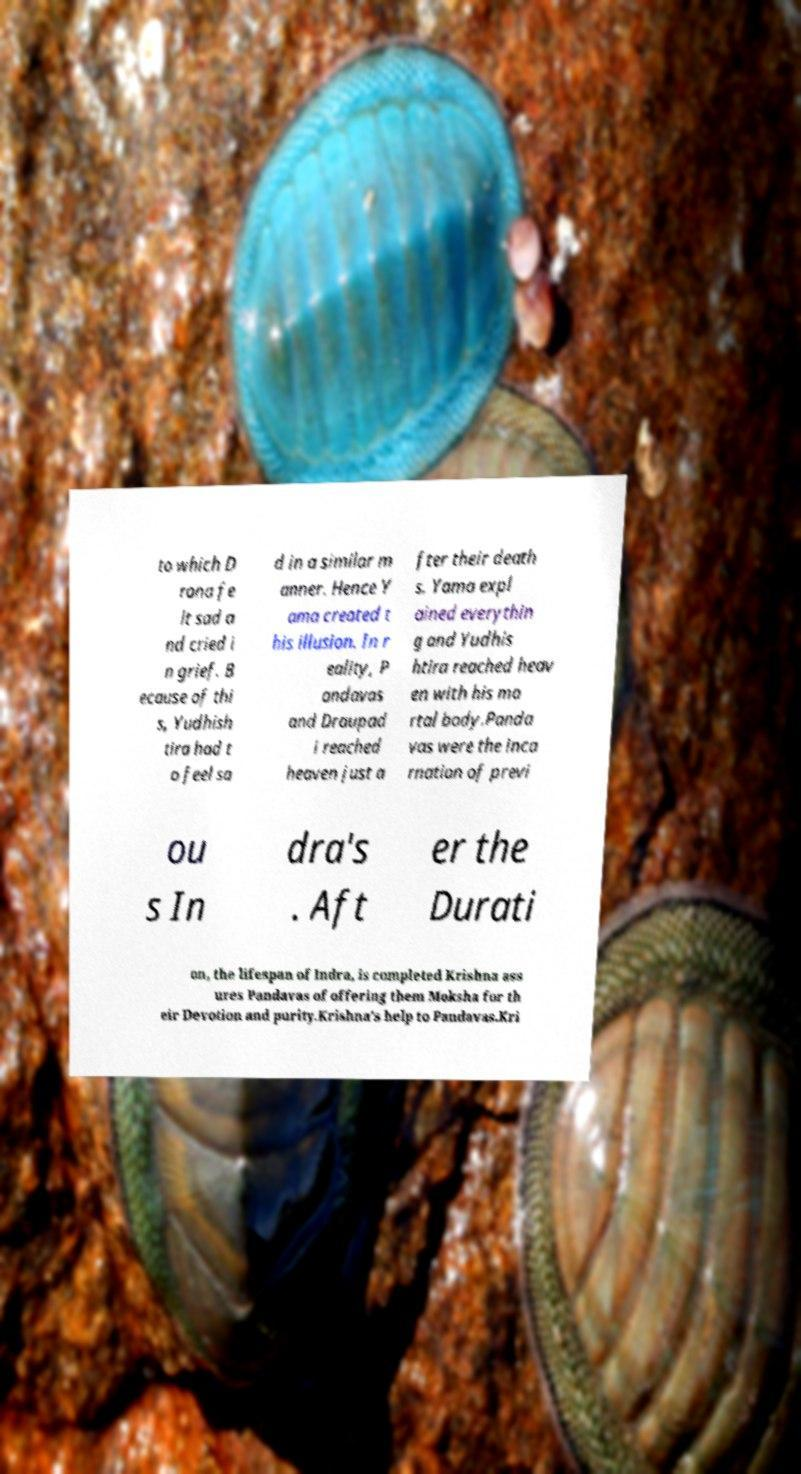I need the written content from this picture converted into text. Can you do that? to which D rona fe lt sad a nd cried i n grief. B ecause of thi s, Yudhish tira had t o feel sa d in a similar m anner. Hence Y ama created t his illusion. In r eality, P andavas and Draupad i reached heaven just a fter their death s. Yama expl ained everythin g and Yudhis htira reached heav en with his mo rtal body.Panda vas were the inca rnation of previ ou s In dra's . Aft er the Durati on, the lifespan of Indra, is completed Krishna ass ures Pandavas of offering them Moksha for th eir Devotion and purity.Krishna's help to Pandavas.Kri 